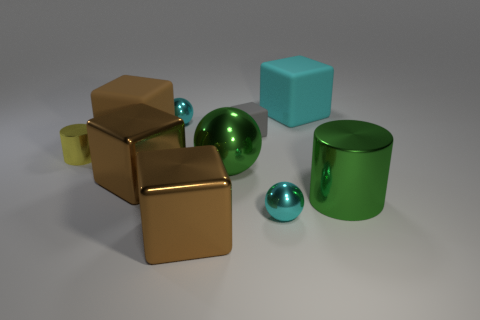Are there any other things that have the same size as the green sphere?
Offer a very short reply. Yes. What is the shape of the small yellow object?
Keep it short and to the point. Cylinder. There is a tiny thing that is made of the same material as the big cyan object; what color is it?
Offer a terse response. Gray. Are there more big shiny cylinders than small green blocks?
Offer a very short reply. Yes. Are any tiny green objects visible?
Offer a terse response. No. What is the shape of the green object on the right side of the rubber object that is on the right side of the tiny gray block?
Make the answer very short. Cylinder. How many things are spheres or blocks behind the small yellow metallic cylinder?
Your answer should be compact. 6. There is a tiny metal thing right of the metal thing in front of the tiny ball that is on the right side of the big green sphere; what is its color?
Make the answer very short. Cyan. There is a big cyan thing that is the same shape as the tiny gray object; what material is it?
Offer a terse response. Rubber. The big sphere has what color?
Offer a terse response. Green. 